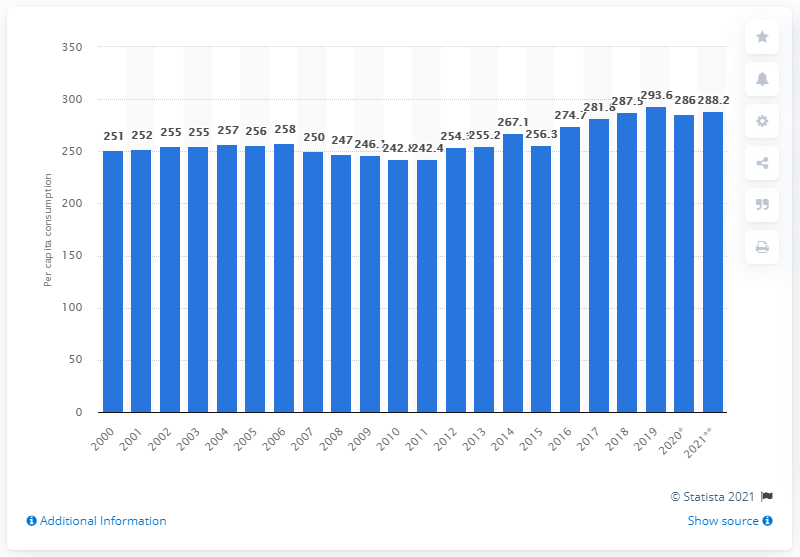Identify some key points in this picture. In the United States in 2019, the average person consumed 293.6 eggs. To determine the average per capita consumption of eggs in the U.S., we take the measure of total egg production, less exports, and divide it by the total U.S. population. The projected consumption of eggs per capita by 2021 was expected to be 288.2 eggs per person. 